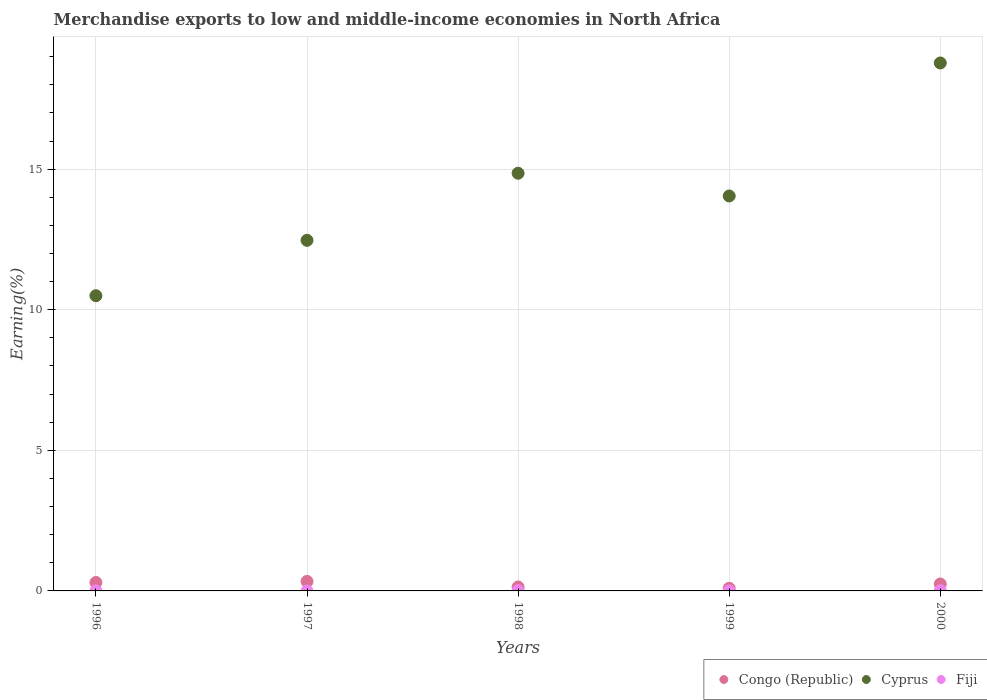Is the number of dotlines equal to the number of legend labels?
Ensure brevity in your answer.  Yes. What is the percentage of amount earned from merchandise exports in Congo (Republic) in 2000?
Your answer should be compact. 0.25. Across all years, what is the maximum percentage of amount earned from merchandise exports in Cyprus?
Offer a very short reply. 18.78. Across all years, what is the minimum percentage of amount earned from merchandise exports in Congo (Republic)?
Your answer should be compact. 0.09. In which year was the percentage of amount earned from merchandise exports in Fiji minimum?
Provide a short and direct response. 1997. What is the total percentage of amount earned from merchandise exports in Fiji in the graph?
Keep it short and to the point. 0.03. What is the difference between the percentage of amount earned from merchandise exports in Congo (Republic) in 1998 and that in 1999?
Your response must be concise. 0.05. What is the difference between the percentage of amount earned from merchandise exports in Fiji in 1997 and the percentage of amount earned from merchandise exports in Cyprus in 1996?
Offer a very short reply. -10.5. What is the average percentage of amount earned from merchandise exports in Fiji per year?
Keep it short and to the point. 0.01. In the year 1998, what is the difference between the percentage of amount earned from merchandise exports in Congo (Republic) and percentage of amount earned from merchandise exports in Fiji?
Your answer should be very brief. 0.13. In how many years, is the percentage of amount earned from merchandise exports in Congo (Republic) greater than 12 %?
Make the answer very short. 0. What is the ratio of the percentage of amount earned from merchandise exports in Cyprus in 1996 to that in 1999?
Give a very brief answer. 0.75. Is the percentage of amount earned from merchandise exports in Congo (Republic) in 1998 less than that in 1999?
Your answer should be very brief. No. Is the difference between the percentage of amount earned from merchandise exports in Congo (Republic) in 1997 and 1998 greater than the difference between the percentage of amount earned from merchandise exports in Fiji in 1997 and 1998?
Your answer should be compact. Yes. What is the difference between the highest and the second highest percentage of amount earned from merchandise exports in Congo (Republic)?
Your answer should be compact. 0.04. What is the difference between the highest and the lowest percentage of amount earned from merchandise exports in Fiji?
Make the answer very short. 0.01. In how many years, is the percentage of amount earned from merchandise exports in Cyprus greater than the average percentage of amount earned from merchandise exports in Cyprus taken over all years?
Ensure brevity in your answer.  2. Are the values on the major ticks of Y-axis written in scientific E-notation?
Provide a short and direct response. No. How many legend labels are there?
Your answer should be very brief. 3. How are the legend labels stacked?
Provide a short and direct response. Horizontal. What is the title of the graph?
Offer a very short reply. Merchandise exports to low and middle-income economies in North Africa. What is the label or title of the Y-axis?
Offer a very short reply. Earning(%). What is the Earning(%) in Congo (Republic) in 1996?
Your answer should be compact. 0.3. What is the Earning(%) in Cyprus in 1996?
Your answer should be very brief. 10.5. What is the Earning(%) in Fiji in 1996?
Provide a short and direct response. 0. What is the Earning(%) in Congo (Republic) in 1997?
Your answer should be very brief. 0.34. What is the Earning(%) of Cyprus in 1997?
Your answer should be very brief. 12.47. What is the Earning(%) of Fiji in 1997?
Give a very brief answer. 0. What is the Earning(%) of Congo (Republic) in 1998?
Make the answer very short. 0.14. What is the Earning(%) of Cyprus in 1998?
Make the answer very short. 14.85. What is the Earning(%) of Fiji in 1998?
Provide a succinct answer. 0.01. What is the Earning(%) in Congo (Republic) in 1999?
Offer a terse response. 0.09. What is the Earning(%) of Cyprus in 1999?
Your response must be concise. 14.05. What is the Earning(%) of Fiji in 1999?
Your answer should be very brief. 0. What is the Earning(%) in Congo (Republic) in 2000?
Your answer should be very brief. 0.25. What is the Earning(%) of Cyprus in 2000?
Make the answer very short. 18.78. What is the Earning(%) in Fiji in 2000?
Keep it short and to the point. 0.01. Across all years, what is the maximum Earning(%) in Congo (Republic)?
Provide a short and direct response. 0.34. Across all years, what is the maximum Earning(%) in Cyprus?
Make the answer very short. 18.78. Across all years, what is the maximum Earning(%) in Fiji?
Give a very brief answer. 0.01. Across all years, what is the minimum Earning(%) of Congo (Republic)?
Give a very brief answer. 0.09. Across all years, what is the minimum Earning(%) of Cyprus?
Your answer should be compact. 10.5. Across all years, what is the minimum Earning(%) of Fiji?
Offer a very short reply. 0. What is the total Earning(%) of Congo (Republic) in the graph?
Your response must be concise. 1.12. What is the total Earning(%) of Cyprus in the graph?
Provide a short and direct response. 70.64. What is the total Earning(%) in Fiji in the graph?
Your answer should be very brief. 0.03. What is the difference between the Earning(%) of Congo (Republic) in 1996 and that in 1997?
Make the answer very short. -0.04. What is the difference between the Earning(%) of Cyprus in 1996 and that in 1997?
Your answer should be compact. -1.97. What is the difference between the Earning(%) in Fiji in 1996 and that in 1997?
Offer a very short reply. 0. What is the difference between the Earning(%) in Congo (Republic) in 1996 and that in 1998?
Your answer should be compact. 0.16. What is the difference between the Earning(%) of Cyprus in 1996 and that in 1998?
Make the answer very short. -4.36. What is the difference between the Earning(%) of Fiji in 1996 and that in 1998?
Keep it short and to the point. -0.01. What is the difference between the Earning(%) of Congo (Republic) in 1996 and that in 1999?
Your response must be concise. 0.21. What is the difference between the Earning(%) of Cyprus in 1996 and that in 1999?
Make the answer very short. -3.55. What is the difference between the Earning(%) in Fiji in 1996 and that in 1999?
Give a very brief answer. 0. What is the difference between the Earning(%) in Congo (Republic) in 1996 and that in 2000?
Give a very brief answer. 0.05. What is the difference between the Earning(%) in Cyprus in 1996 and that in 2000?
Provide a short and direct response. -8.28. What is the difference between the Earning(%) in Fiji in 1996 and that in 2000?
Your answer should be compact. -0.01. What is the difference between the Earning(%) in Congo (Republic) in 1997 and that in 1998?
Provide a succinct answer. 0.2. What is the difference between the Earning(%) of Cyprus in 1997 and that in 1998?
Provide a short and direct response. -2.39. What is the difference between the Earning(%) of Fiji in 1997 and that in 1998?
Offer a terse response. -0.01. What is the difference between the Earning(%) in Congo (Republic) in 1997 and that in 1999?
Make the answer very short. 0.24. What is the difference between the Earning(%) of Cyprus in 1997 and that in 1999?
Offer a terse response. -1.58. What is the difference between the Earning(%) in Fiji in 1997 and that in 1999?
Keep it short and to the point. -0. What is the difference between the Earning(%) in Congo (Republic) in 1997 and that in 2000?
Offer a terse response. 0.09. What is the difference between the Earning(%) of Cyprus in 1997 and that in 2000?
Provide a succinct answer. -6.31. What is the difference between the Earning(%) in Fiji in 1997 and that in 2000?
Offer a very short reply. -0.01. What is the difference between the Earning(%) in Congo (Republic) in 1998 and that in 1999?
Provide a succinct answer. 0.05. What is the difference between the Earning(%) in Cyprus in 1998 and that in 1999?
Your response must be concise. 0.81. What is the difference between the Earning(%) of Fiji in 1998 and that in 1999?
Ensure brevity in your answer.  0.01. What is the difference between the Earning(%) of Congo (Republic) in 1998 and that in 2000?
Provide a short and direct response. -0.11. What is the difference between the Earning(%) in Cyprus in 1998 and that in 2000?
Provide a short and direct response. -3.92. What is the difference between the Earning(%) of Fiji in 1998 and that in 2000?
Make the answer very short. 0. What is the difference between the Earning(%) in Congo (Republic) in 1999 and that in 2000?
Ensure brevity in your answer.  -0.15. What is the difference between the Earning(%) of Cyprus in 1999 and that in 2000?
Ensure brevity in your answer.  -4.73. What is the difference between the Earning(%) of Fiji in 1999 and that in 2000?
Offer a very short reply. -0.01. What is the difference between the Earning(%) of Congo (Republic) in 1996 and the Earning(%) of Cyprus in 1997?
Offer a very short reply. -12.17. What is the difference between the Earning(%) of Congo (Republic) in 1996 and the Earning(%) of Fiji in 1997?
Your answer should be compact. 0.3. What is the difference between the Earning(%) in Cyprus in 1996 and the Earning(%) in Fiji in 1997?
Your answer should be very brief. 10.5. What is the difference between the Earning(%) of Congo (Republic) in 1996 and the Earning(%) of Cyprus in 1998?
Your answer should be compact. -14.55. What is the difference between the Earning(%) in Congo (Republic) in 1996 and the Earning(%) in Fiji in 1998?
Your response must be concise. 0.29. What is the difference between the Earning(%) of Cyprus in 1996 and the Earning(%) of Fiji in 1998?
Provide a succinct answer. 10.49. What is the difference between the Earning(%) in Congo (Republic) in 1996 and the Earning(%) in Cyprus in 1999?
Give a very brief answer. -13.74. What is the difference between the Earning(%) in Congo (Republic) in 1996 and the Earning(%) in Fiji in 1999?
Offer a terse response. 0.3. What is the difference between the Earning(%) of Cyprus in 1996 and the Earning(%) of Fiji in 1999?
Offer a terse response. 10.5. What is the difference between the Earning(%) of Congo (Republic) in 1996 and the Earning(%) of Cyprus in 2000?
Your answer should be compact. -18.48. What is the difference between the Earning(%) in Congo (Republic) in 1996 and the Earning(%) in Fiji in 2000?
Give a very brief answer. 0.29. What is the difference between the Earning(%) in Cyprus in 1996 and the Earning(%) in Fiji in 2000?
Ensure brevity in your answer.  10.49. What is the difference between the Earning(%) in Congo (Republic) in 1997 and the Earning(%) in Cyprus in 1998?
Offer a terse response. -14.52. What is the difference between the Earning(%) of Congo (Republic) in 1997 and the Earning(%) of Fiji in 1998?
Make the answer very short. 0.32. What is the difference between the Earning(%) of Cyprus in 1997 and the Earning(%) of Fiji in 1998?
Ensure brevity in your answer.  12.45. What is the difference between the Earning(%) in Congo (Republic) in 1997 and the Earning(%) in Cyprus in 1999?
Make the answer very short. -13.71. What is the difference between the Earning(%) of Congo (Republic) in 1997 and the Earning(%) of Fiji in 1999?
Your answer should be compact. 0.34. What is the difference between the Earning(%) of Cyprus in 1997 and the Earning(%) of Fiji in 1999?
Ensure brevity in your answer.  12.47. What is the difference between the Earning(%) of Congo (Republic) in 1997 and the Earning(%) of Cyprus in 2000?
Your answer should be very brief. -18.44. What is the difference between the Earning(%) in Congo (Republic) in 1997 and the Earning(%) in Fiji in 2000?
Your answer should be compact. 0.33. What is the difference between the Earning(%) in Cyprus in 1997 and the Earning(%) in Fiji in 2000?
Make the answer very short. 12.46. What is the difference between the Earning(%) in Congo (Republic) in 1998 and the Earning(%) in Cyprus in 1999?
Give a very brief answer. -13.9. What is the difference between the Earning(%) of Congo (Republic) in 1998 and the Earning(%) of Fiji in 1999?
Offer a terse response. 0.14. What is the difference between the Earning(%) in Cyprus in 1998 and the Earning(%) in Fiji in 1999?
Your answer should be compact. 14.85. What is the difference between the Earning(%) of Congo (Republic) in 1998 and the Earning(%) of Cyprus in 2000?
Keep it short and to the point. -18.63. What is the difference between the Earning(%) in Congo (Republic) in 1998 and the Earning(%) in Fiji in 2000?
Make the answer very short. 0.13. What is the difference between the Earning(%) in Cyprus in 1998 and the Earning(%) in Fiji in 2000?
Ensure brevity in your answer.  14.84. What is the difference between the Earning(%) of Congo (Republic) in 1999 and the Earning(%) of Cyprus in 2000?
Offer a very short reply. -18.68. What is the difference between the Earning(%) of Congo (Republic) in 1999 and the Earning(%) of Fiji in 2000?
Provide a short and direct response. 0.08. What is the difference between the Earning(%) of Cyprus in 1999 and the Earning(%) of Fiji in 2000?
Ensure brevity in your answer.  14.04. What is the average Earning(%) of Congo (Republic) per year?
Provide a short and direct response. 0.22. What is the average Earning(%) of Cyprus per year?
Give a very brief answer. 14.13. What is the average Earning(%) in Fiji per year?
Offer a terse response. 0.01. In the year 1996, what is the difference between the Earning(%) of Congo (Republic) and Earning(%) of Cyprus?
Your answer should be very brief. -10.2. In the year 1996, what is the difference between the Earning(%) in Congo (Republic) and Earning(%) in Fiji?
Ensure brevity in your answer.  0.3. In the year 1996, what is the difference between the Earning(%) in Cyprus and Earning(%) in Fiji?
Your response must be concise. 10.5. In the year 1997, what is the difference between the Earning(%) of Congo (Republic) and Earning(%) of Cyprus?
Your response must be concise. -12.13. In the year 1997, what is the difference between the Earning(%) of Congo (Republic) and Earning(%) of Fiji?
Make the answer very short. 0.34. In the year 1997, what is the difference between the Earning(%) of Cyprus and Earning(%) of Fiji?
Provide a succinct answer. 12.47. In the year 1998, what is the difference between the Earning(%) of Congo (Republic) and Earning(%) of Cyprus?
Your answer should be compact. -14.71. In the year 1998, what is the difference between the Earning(%) of Congo (Republic) and Earning(%) of Fiji?
Offer a terse response. 0.13. In the year 1998, what is the difference between the Earning(%) of Cyprus and Earning(%) of Fiji?
Your answer should be compact. 14.84. In the year 1999, what is the difference between the Earning(%) in Congo (Republic) and Earning(%) in Cyprus?
Keep it short and to the point. -13.95. In the year 1999, what is the difference between the Earning(%) in Congo (Republic) and Earning(%) in Fiji?
Make the answer very short. 0.09. In the year 1999, what is the difference between the Earning(%) of Cyprus and Earning(%) of Fiji?
Offer a very short reply. 14.04. In the year 2000, what is the difference between the Earning(%) in Congo (Republic) and Earning(%) in Cyprus?
Offer a terse response. -18.53. In the year 2000, what is the difference between the Earning(%) of Congo (Republic) and Earning(%) of Fiji?
Your answer should be very brief. 0.24. In the year 2000, what is the difference between the Earning(%) of Cyprus and Earning(%) of Fiji?
Provide a short and direct response. 18.77. What is the ratio of the Earning(%) in Congo (Republic) in 1996 to that in 1997?
Provide a succinct answer. 0.89. What is the ratio of the Earning(%) of Cyprus in 1996 to that in 1997?
Offer a very short reply. 0.84. What is the ratio of the Earning(%) in Fiji in 1996 to that in 1997?
Ensure brevity in your answer.  21.87. What is the ratio of the Earning(%) in Congo (Republic) in 1996 to that in 1998?
Ensure brevity in your answer.  2.13. What is the ratio of the Earning(%) in Cyprus in 1996 to that in 1998?
Your answer should be compact. 0.71. What is the ratio of the Earning(%) in Fiji in 1996 to that in 1998?
Your response must be concise. 0.18. What is the ratio of the Earning(%) of Congo (Republic) in 1996 to that in 1999?
Offer a terse response. 3.18. What is the ratio of the Earning(%) of Cyprus in 1996 to that in 1999?
Make the answer very short. 0.75. What is the ratio of the Earning(%) of Fiji in 1996 to that in 1999?
Your answer should be compact. 1.82. What is the ratio of the Earning(%) of Congo (Republic) in 1996 to that in 2000?
Ensure brevity in your answer.  1.22. What is the ratio of the Earning(%) of Cyprus in 1996 to that in 2000?
Ensure brevity in your answer.  0.56. What is the ratio of the Earning(%) of Fiji in 1996 to that in 2000?
Offer a terse response. 0.23. What is the ratio of the Earning(%) in Congo (Republic) in 1997 to that in 1998?
Ensure brevity in your answer.  2.4. What is the ratio of the Earning(%) in Cyprus in 1997 to that in 1998?
Ensure brevity in your answer.  0.84. What is the ratio of the Earning(%) in Fiji in 1997 to that in 1998?
Make the answer very short. 0.01. What is the ratio of the Earning(%) in Congo (Republic) in 1997 to that in 1999?
Provide a short and direct response. 3.58. What is the ratio of the Earning(%) of Cyprus in 1997 to that in 1999?
Your answer should be compact. 0.89. What is the ratio of the Earning(%) of Fiji in 1997 to that in 1999?
Give a very brief answer. 0.08. What is the ratio of the Earning(%) in Congo (Republic) in 1997 to that in 2000?
Offer a very short reply. 1.37. What is the ratio of the Earning(%) of Cyprus in 1997 to that in 2000?
Your answer should be compact. 0.66. What is the ratio of the Earning(%) in Fiji in 1997 to that in 2000?
Your answer should be compact. 0.01. What is the ratio of the Earning(%) of Congo (Republic) in 1998 to that in 1999?
Ensure brevity in your answer.  1.49. What is the ratio of the Earning(%) in Cyprus in 1998 to that in 1999?
Make the answer very short. 1.06. What is the ratio of the Earning(%) of Fiji in 1998 to that in 1999?
Offer a terse response. 9.84. What is the ratio of the Earning(%) in Congo (Republic) in 1998 to that in 2000?
Your answer should be compact. 0.57. What is the ratio of the Earning(%) in Cyprus in 1998 to that in 2000?
Offer a very short reply. 0.79. What is the ratio of the Earning(%) in Fiji in 1998 to that in 2000?
Offer a terse response. 1.25. What is the ratio of the Earning(%) of Congo (Republic) in 1999 to that in 2000?
Provide a succinct answer. 0.38. What is the ratio of the Earning(%) of Cyprus in 1999 to that in 2000?
Keep it short and to the point. 0.75. What is the ratio of the Earning(%) in Fiji in 1999 to that in 2000?
Your answer should be very brief. 0.13. What is the difference between the highest and the second highest Earning(%) of Congo (Republic)?
Make the answer very short. 0.04. What is the difference between the highest and the second highest Earning(%) in Cyprus?
Ensure brevity in your answer.  3.92. What is the difference between the highest and the second highest Earning(%) of Fiji?
Make the answer very short. 0. What is the difference between the highest and the lowest Earning(%) of Congo (Republic)?
Give a very brief answer. 0.24. What is the difference between the highest and the lowest Earning(%) in Cyprus?
Offer a terse response. 8.28. What is the difference between the highest and the lowest Earning(%) in Fiji?
Offer a terse response. 0.01. 